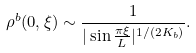<formula> <loc_0><loc_0><loc_500><loc_500>\rho ^ { b } ( 0 , \xi ) \sim \frac { 1 } { | \sin { \frac { \pi \xi } { L } } | ^ { 1 / ( 2 K _ { b } ) } } .</formula> 